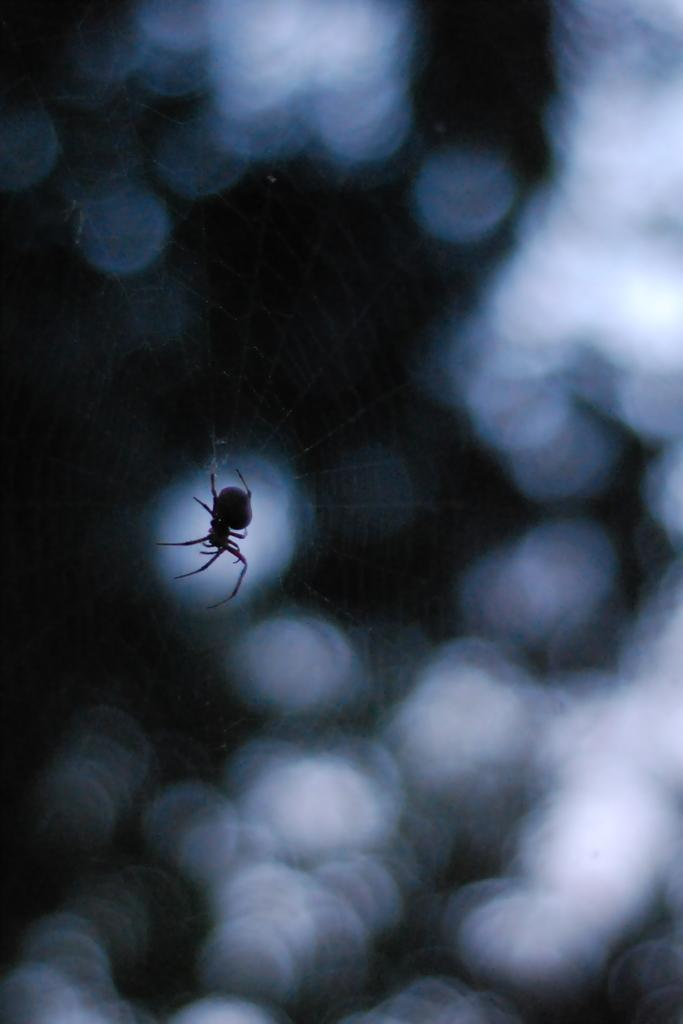What is the main subject of the picture? The main subject of the picture is a spider. Where is the spider located in the image? The spider is on a web. Can you describe the background of the image? The background of the image is not clear. What type of drink is the spider holding in the image? There is no drink present in the image, as the spider is on a web and not holding any object. 